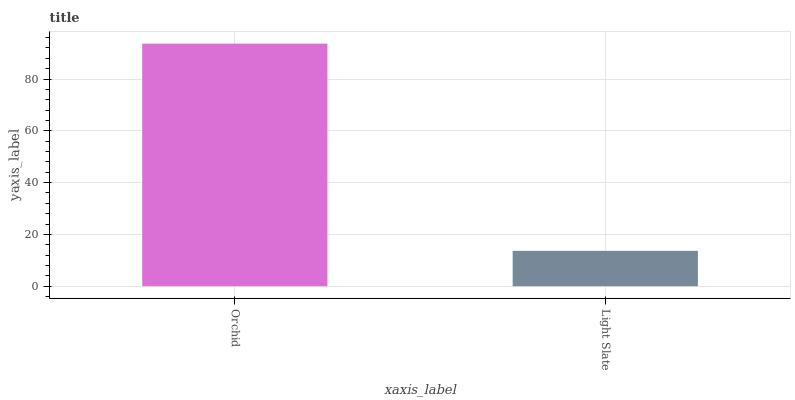Is Light Slate the minimum?
Answer yes or no. Yes. Is Orchid the maximum?
Answer yes or no. Yes. Is Light Slate the maximum?
Answer yes or no. No. Is Orchid greater than Light Slate?
Answer yes or no. Yes. Is Light Slate less than Orchid?
Answer yes or no. Yes. Is Light Slate greater than Orchid?
Answer yes or no. No. Is Orchid less than Light Slate?
Answer yes or no. No. Is Orchid the high median?
Answer yes or no. Yes. Is Light Slate the low median?
Answer yes or no. Yes. Is Light Slate the high median?
Answer yes or no. No. Is Orchid the low median?
Answer yes or no. No. 